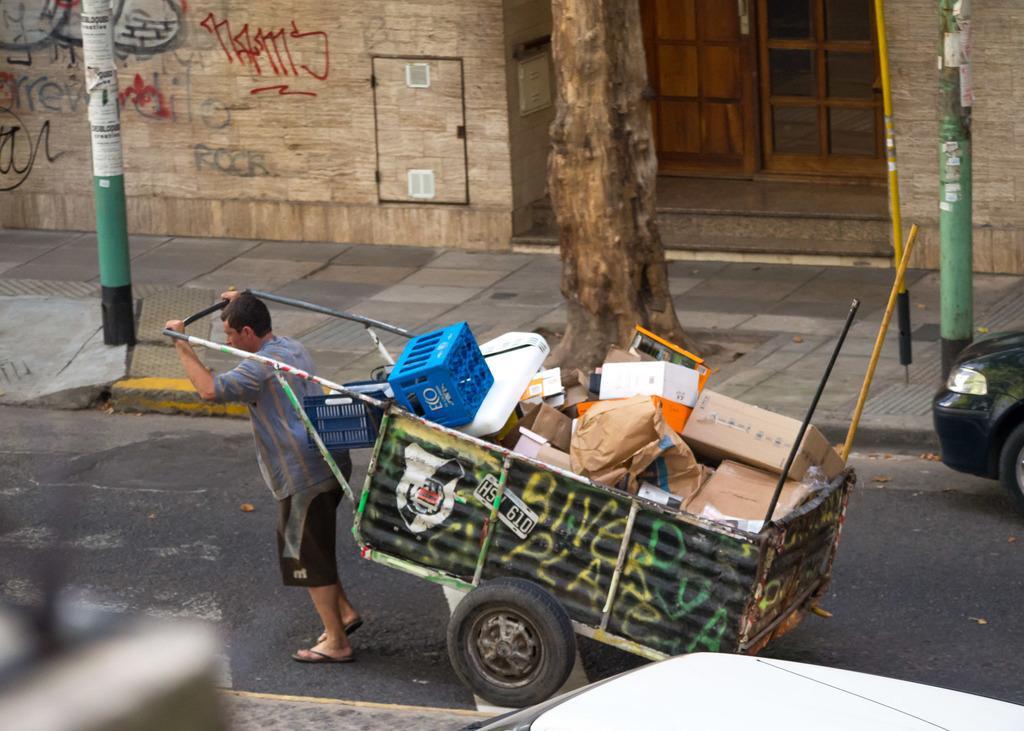Can you describe this image briefly? In the foreground of the picture there is a vehicle and footpath. In the center of the picture we can see a man pulling a cart on the road. On the right there is a car. At the top there are poles, tree, footpath, building and a door. 